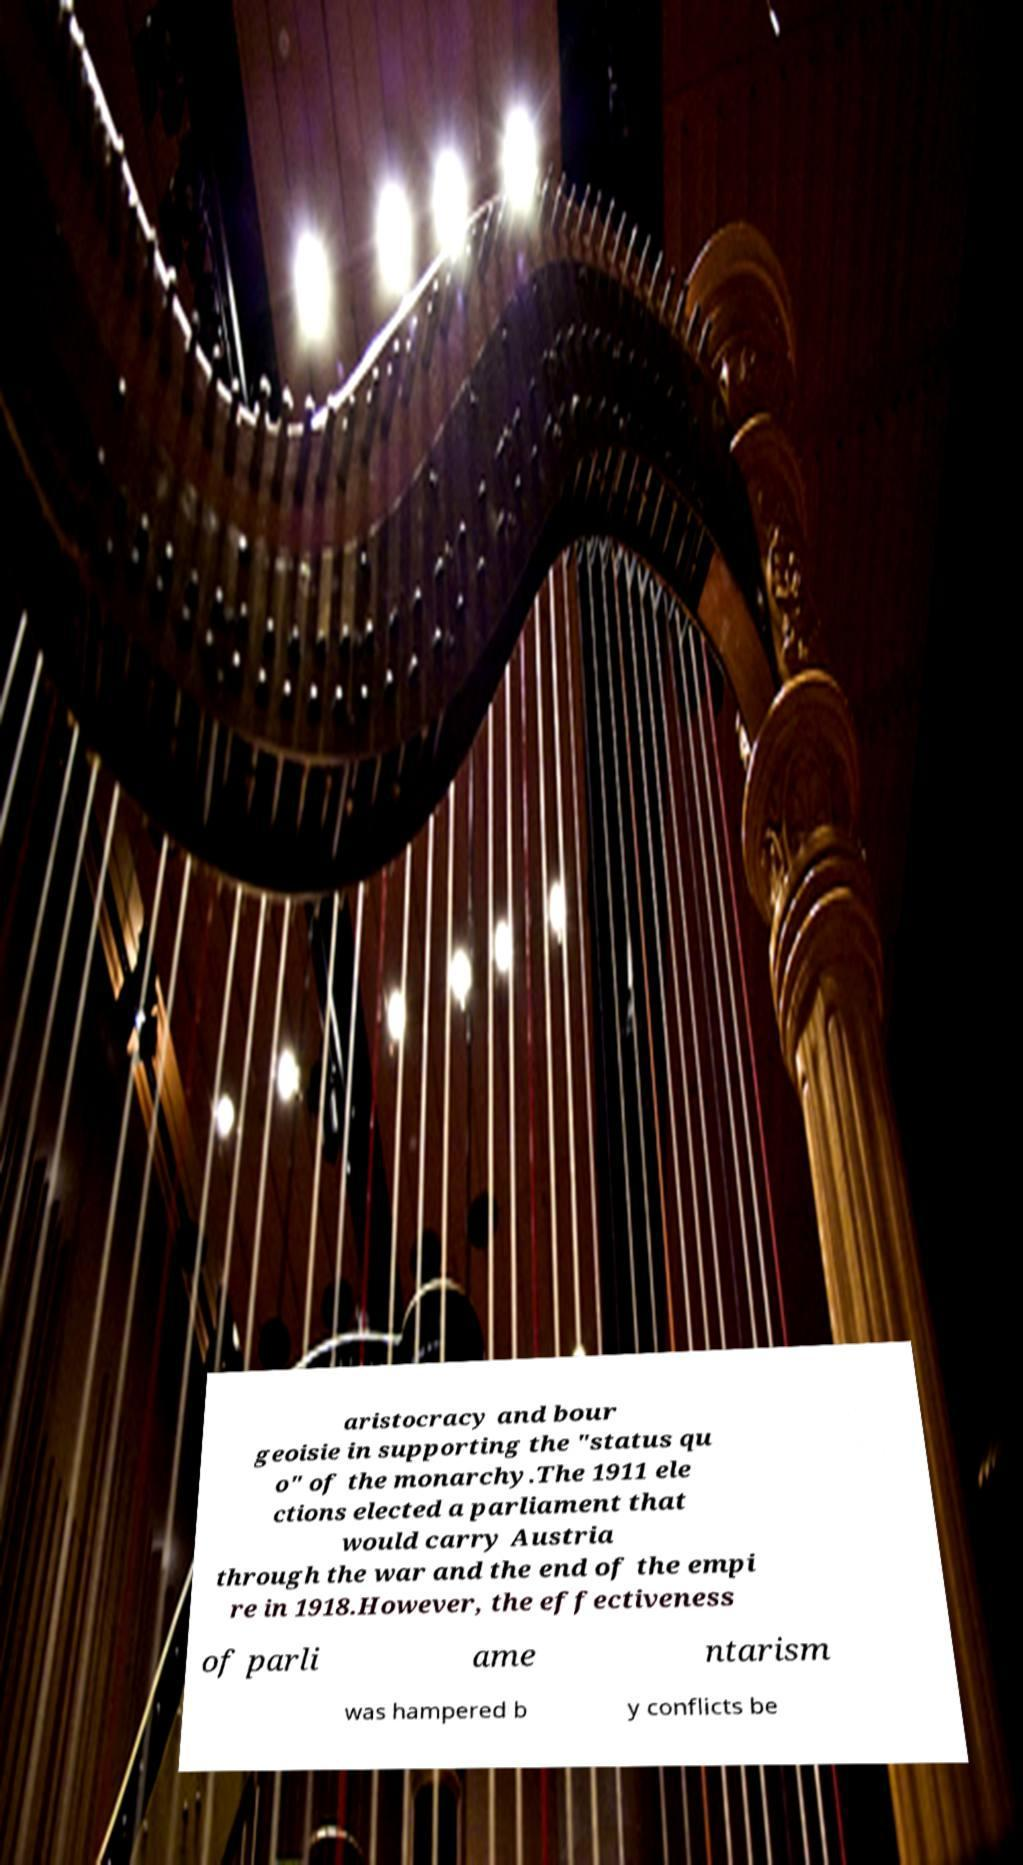Could you extract and type out the text from this image? aristocracy and bour geoisie in supporting the "status qu o" of the monarchy.The 1911 ele ctions elected a parliament that would carry Austria through the war and the end of the empi re in 1918.However, the effectiveness of parli ame ntarism was hampered b y conflicts be 